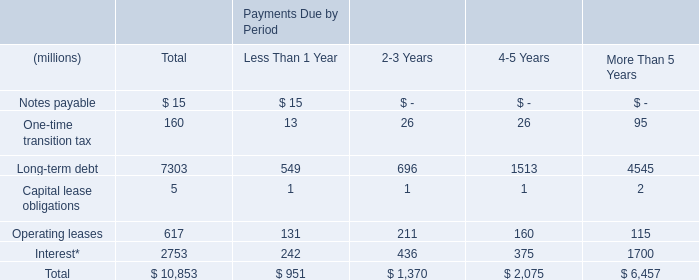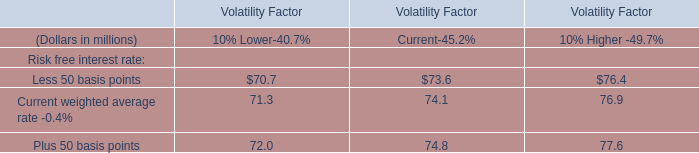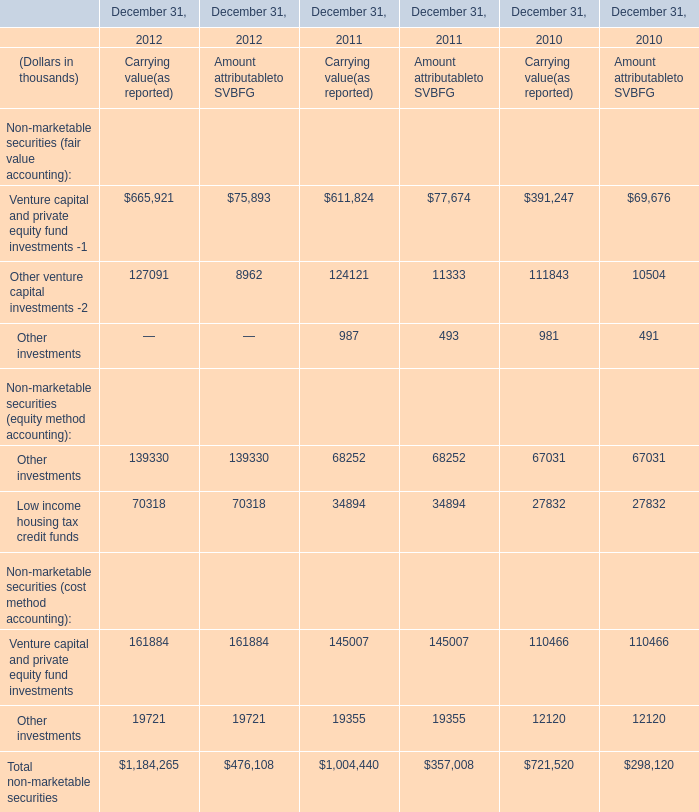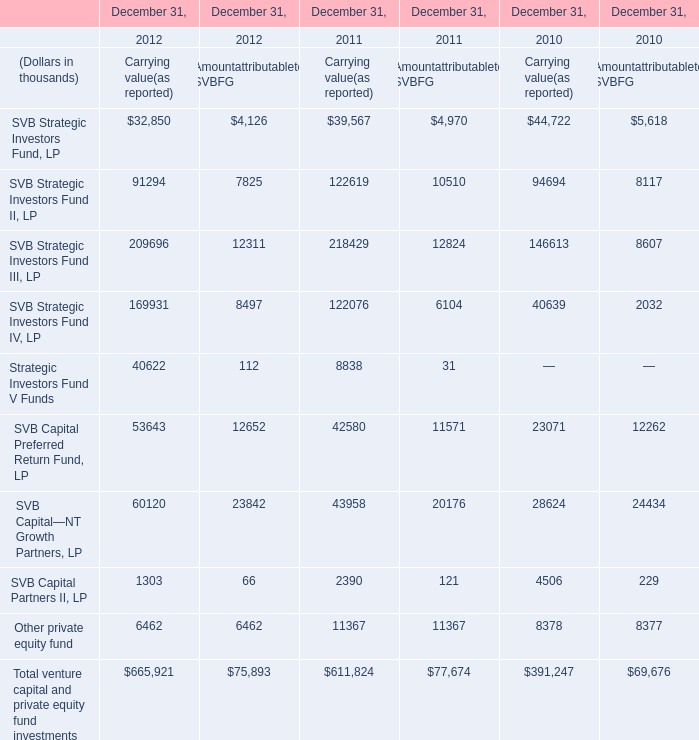In what sections is SVB Strategic Investors Fund, LP positive? 
Answer: Carrying value(as reported) Amountattributableto SVBFG. 